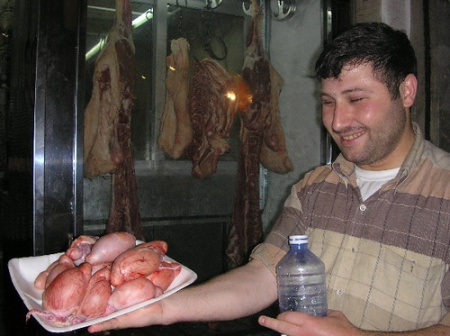Can you elaborate on the elements of the picture provided?
 In the image, a man is standing in front of a window display that showcases hanging meats. He is holding a white plate that contains raw, pink meat. The man is wearing a striped shirt and has a smile on his face, suggesting he might be proud or satisfied with the meat he's holding. 

The window display behind him is lit up, contrasting with the dark background, and features three pieces of hanging meat. Two of these meats are brown, possibly indicating they are smoked or cured, while the third one is pink, similar to the meat on the man's plate. 

The man's position in front of the window display, along with his plate of meat, suggests he might be a butcher or a meat enthusiast. The image does not contain any text or other discernible objects. The relative positions of the objects indicate that the man is the main subject of the image, with the window display serving as a backdrop to highlight his profession or interest. 